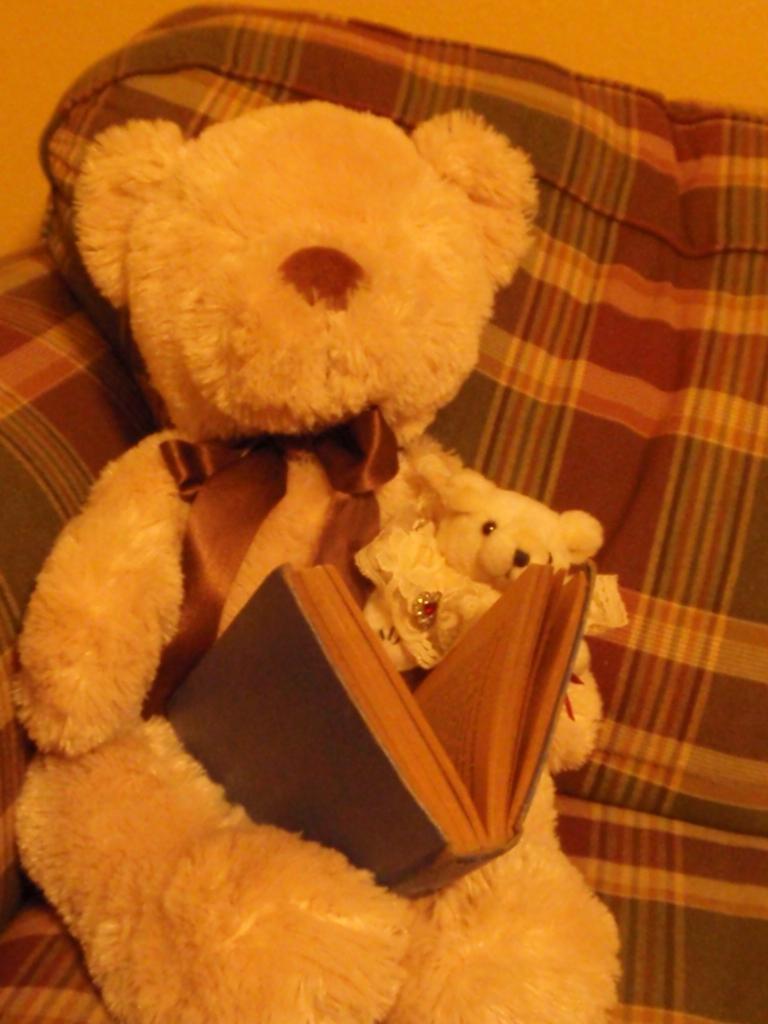Describe this image in one or two sentences. In this image we can see a soft toy which looks like a teddy bear and there is a book on it and we can see a couch. 